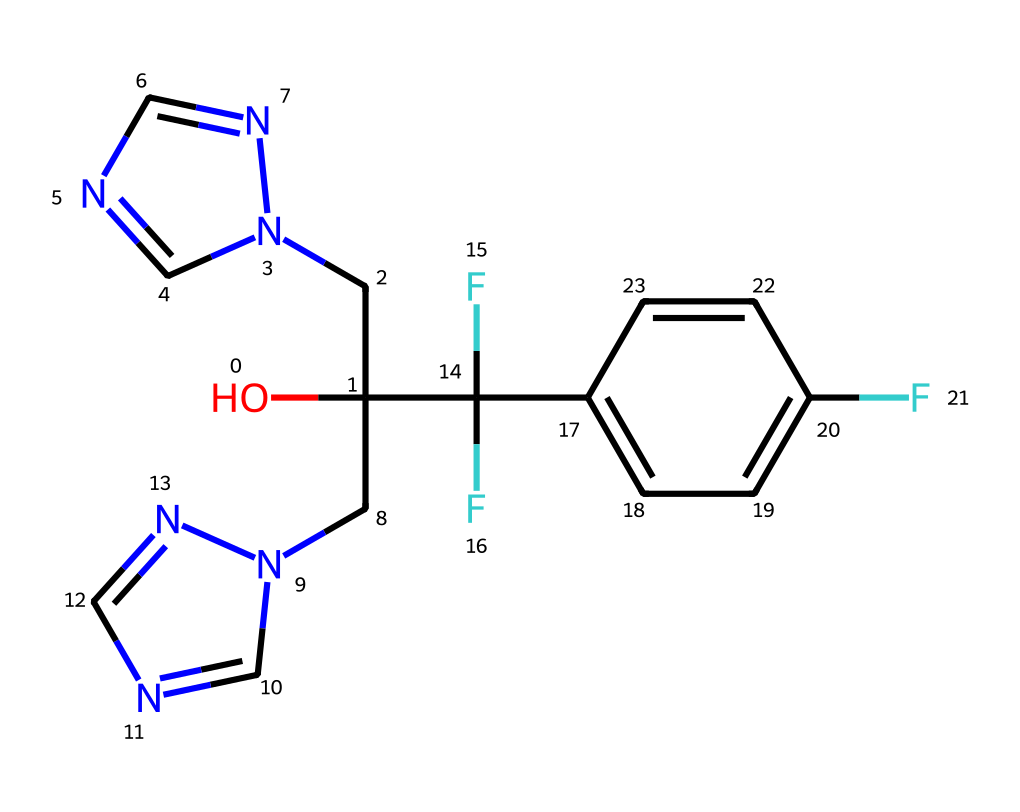What is the molecular formula of fluconazole? To determine the molecular formula from the SMILES notation, we need to identify the elements and their respective counts. The SMILES reveals the presence of carbon (C), hydrogen (H), nitrogen (N), and fluorine (F). Counting them gives us C14, H16, F3, N4, which fits the molecular formula.
Answer: C14H16F3N4 How many nitrogen atoms are in this compound? Analyzing the structure from the SMILES representation, we see there are four instances of 'n' denoting nitrogen atoms. Therefore, the count of nitrogen atoms is four.
Answer: four Does this compound contain any fluorine atoms? Yes, the presence of 'F' in the SMILES indicates that there are fluorine atoms present in the structure. Counting them shows there are three fluorine atoms.
Answer: three What type of functional group is primarily present in fluconazole? From the structure indicated in the SMILES, the alcohol group (denoted by 'OH') suggests this compound contains a hydroxyl functional group, which is characteristic of alcohols.
Answer: hydroxyl Is fluconazole a single molecule or a polymer? The SMILES code represents fluconazole as a singular complex chemical structure without repeating units, indicating that it is a single molecule rather than a polymer.
Answer: single molecule What characteristic feature suggests fluconazole is an antifungal agent? The presence of multiple nitrogen atoms linked in a fused ring structure is typical of a large class of antifungal compounds, suggesting significant pharmacological activity in the structure.
Answer: multiple nitrogen atoms How many rings are present in the structure of fluconazole? Upon inspection of the SMILES, we can identify two fused rings, which is common in many drugs, particularly antifungals. The pattern indicates there are two distinct ring systems present.
Answer: two rings 